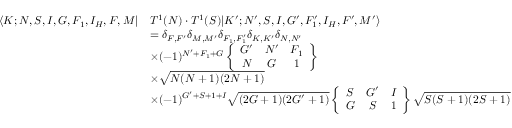<formula> <loc_0><loc_0><loc_500><loc_500>\begin{array} { r l } { \langle K ; N , S , I , G , F _ { 1 } , I _ { H } , F , M | } & { T ^ { 1 } ( N ) \cdot T ^ { 1 } ( S ) | K ^ { \prime } ; N ^ { \prime } , S , I , G ^ { \prime } , F _ { 1 } ^ { \prime } , I _ { H } , F ^ { \prime } , M ^ { \prime } \rangle } \\ & { = \delta _ { F , F ^ { \prime } } \delta _ { M , M ^ { \prime } } \delta _ { F _ { 1 } , F _ { 1 } ^ { \prime } } \delta _ { K , K ^ { \prime } } \delta _ { N , N ^ { \prime } } } \\ & { \times ( - 1 ) ^ { N ^ { \prime } + F _ { 1 } + G } \left \{ \begin{array} { c c c } { G ^ { \prime } } & { N ^ { \prime } } & { F _ { 1 } } \\ { N } & { G } & { 1 } \end{array} \right \} } \\ & { \times \sqrt { N ( N + 1 ) ( 2 N + 1 ) } } \\ & { \times ( - 1 ) ^ { G ^ { \prime } + S + 1 + I } \sqrt { ( 2 G + 1 ) ( 2 G ^ { \prime } + 1 ) } \left \{ \begin{array} { c c c } { S } & { G ^ { \prime } } & { I } \\ { G } & { S } & { 1 } \end{array} \right \} \sqrt { S ( S + 1 ) ( 2 S + 1 ) } } \end{array}</formula> 